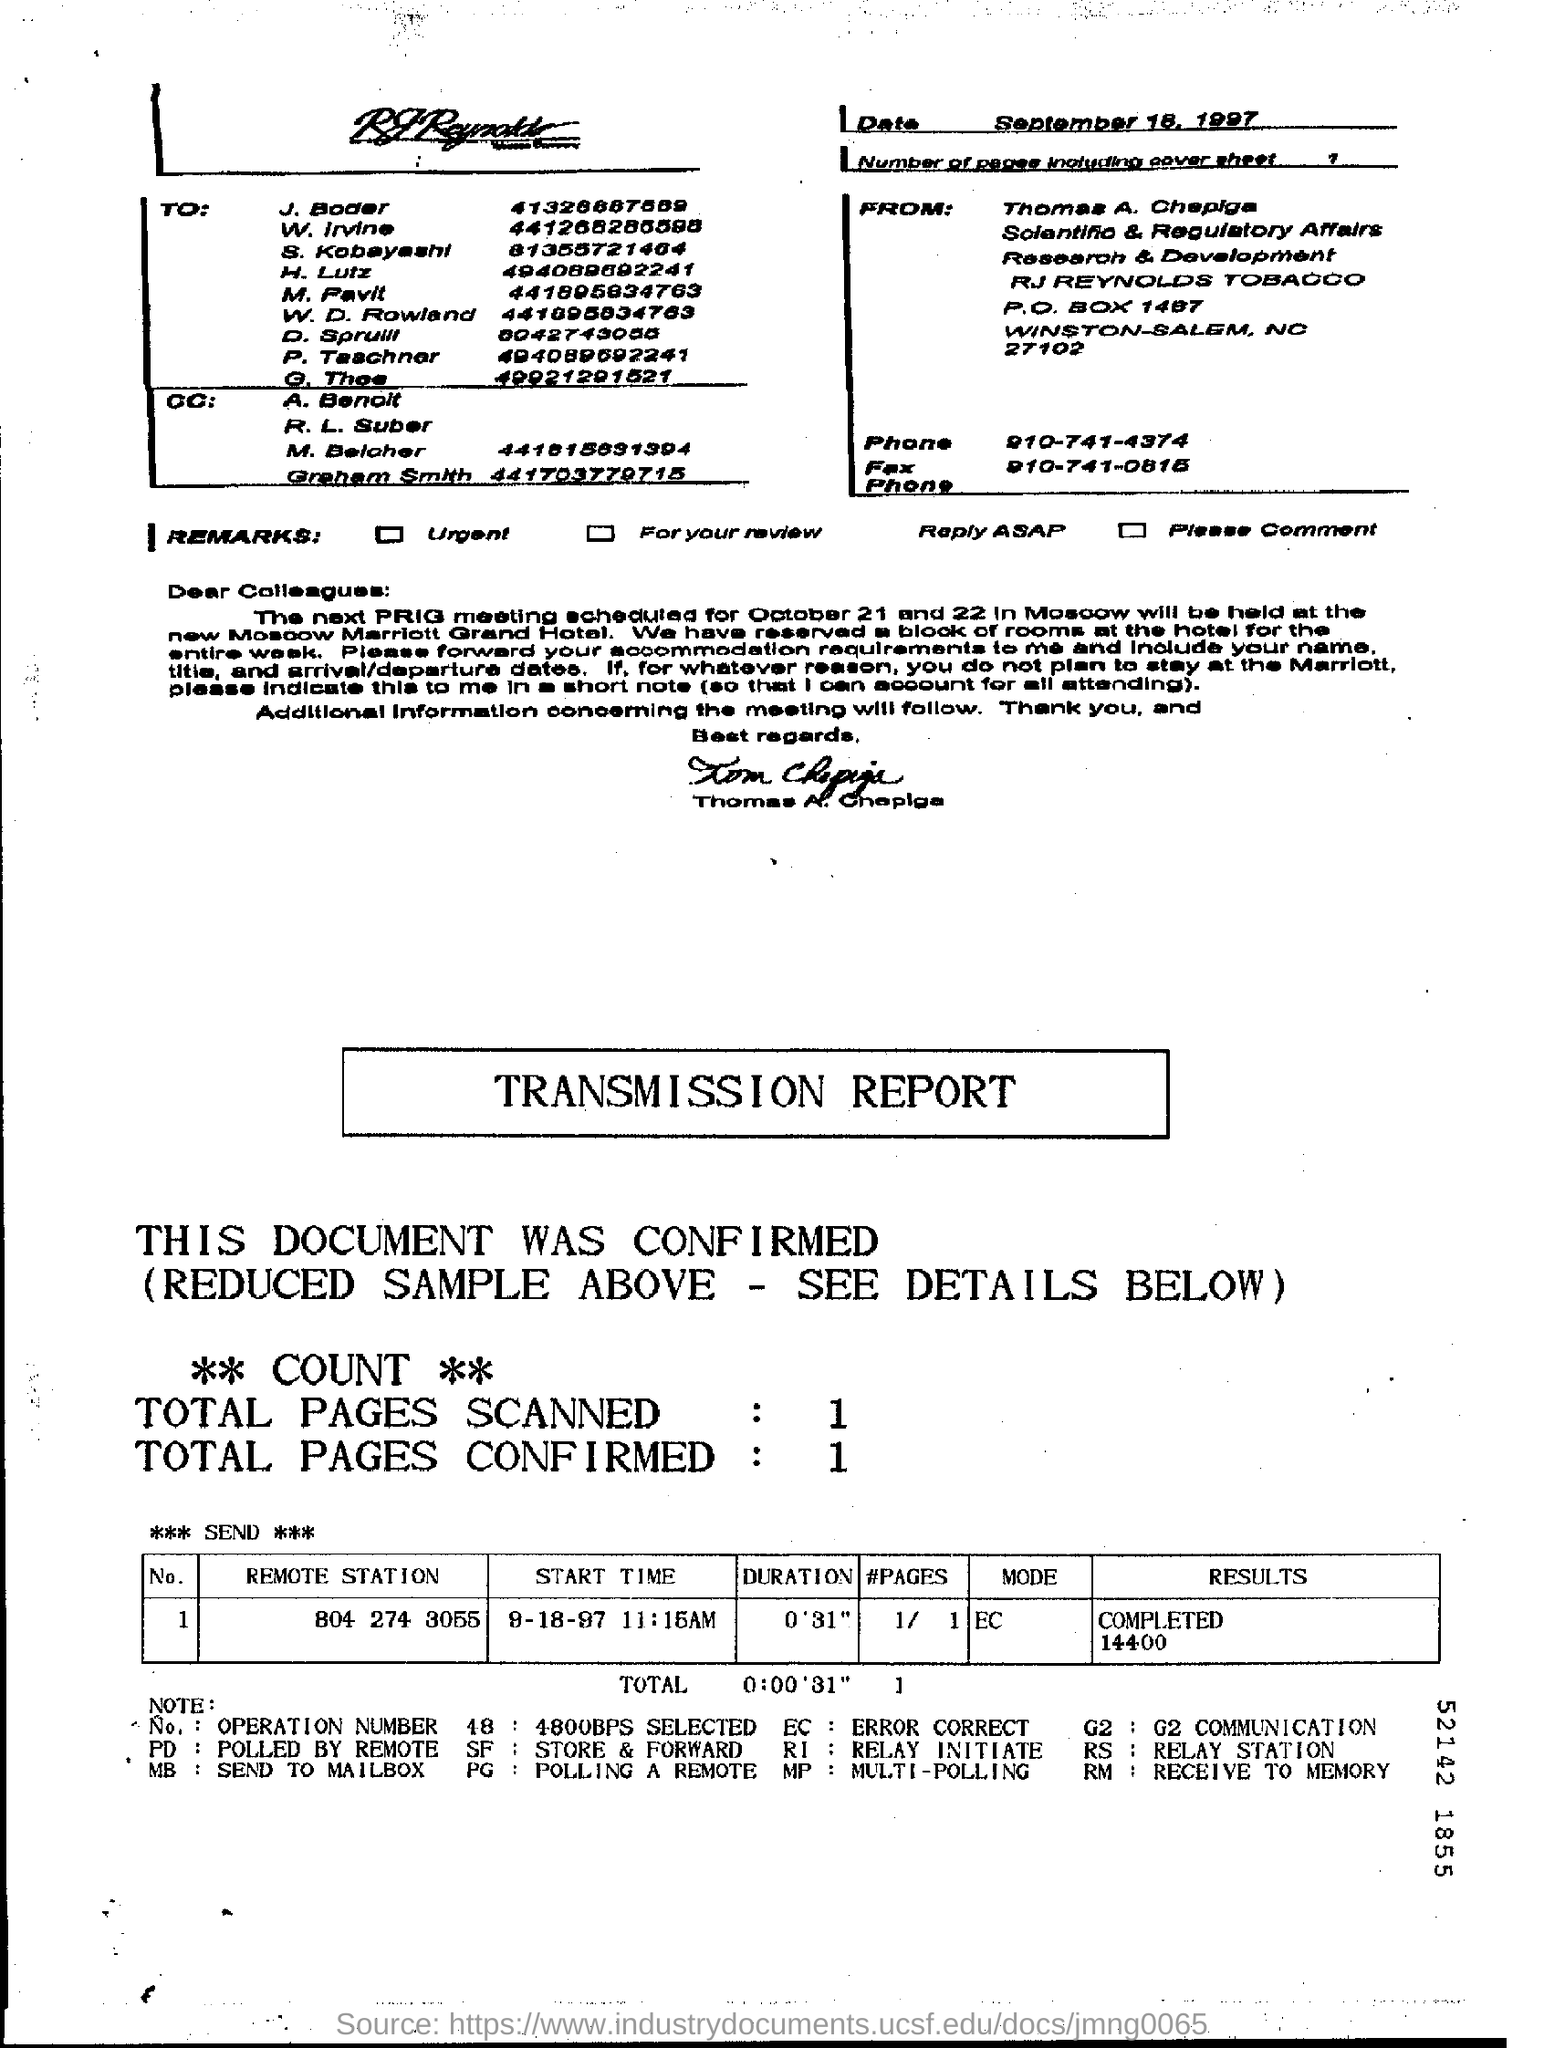How many number of pages (including cover sheet) are there ?
Keep it short and to the point. 1. How many total pages are scanned ?
Provide a short and direct response. 1. 